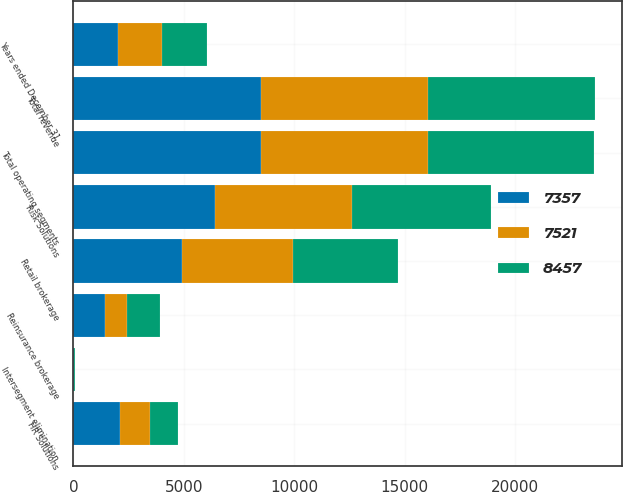<chart> <loc_0><loc_0><loc_500><loc_500><stacked_bar_chart><ecel><fcel>Years ended December 31<fcel>Risk Solutions<fcel>HR Solutions<fcel>Intersegment elimination<fcel>Total operating segments<fcel>Total revenue<fcel>Retail brokerage<fcel>Reinsurance brokerage<nl><fcel>7357<fcel>2010<fcel>6423<fcel>2111<fcel>22<fcel>8512<fcel>8512<fcel>4925<fcel>1444<nl><fcel>8457<fcel>2009<fcel>6305<fcel>1267<fcel>26<fcel>7546<fcel>7595<fcel>4747<fcel>1485<nl><fcel>7521<fcel>2008<fcel>6197<fcel>1356<fcel>25<fcel>7528<fcel>7528<fcel>5028<fcel>1001<nl></chart> 